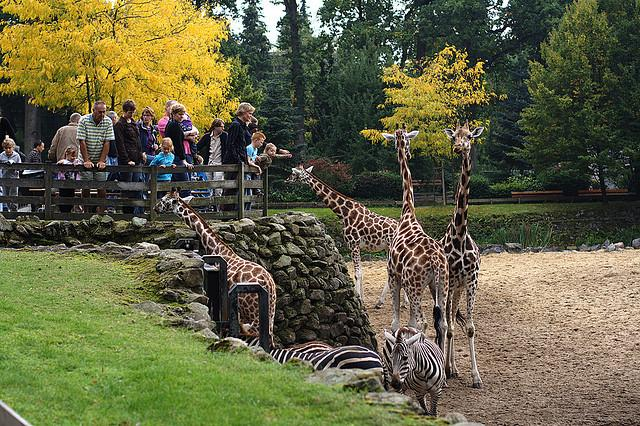How many giraffes are standing in the zoo enclosure around the people? Please explain your reasoning. four. Two giraffes are standing by two other giraffes. 